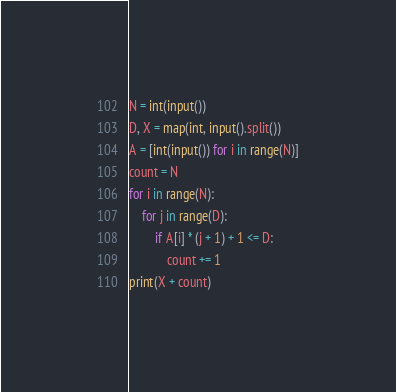Convert code to text. <code><loc_0><loc_0><loc_500><loc_500><_Python_>N = int(input())
D, X = map(int, input().split())
A = [int(input()) for i in range(N)]
count = N
for i in range(N):
	for j in range(D):
		if A[i] * (j + 1) + 1 <= D:
			count += 1
print(X + count)</code> 